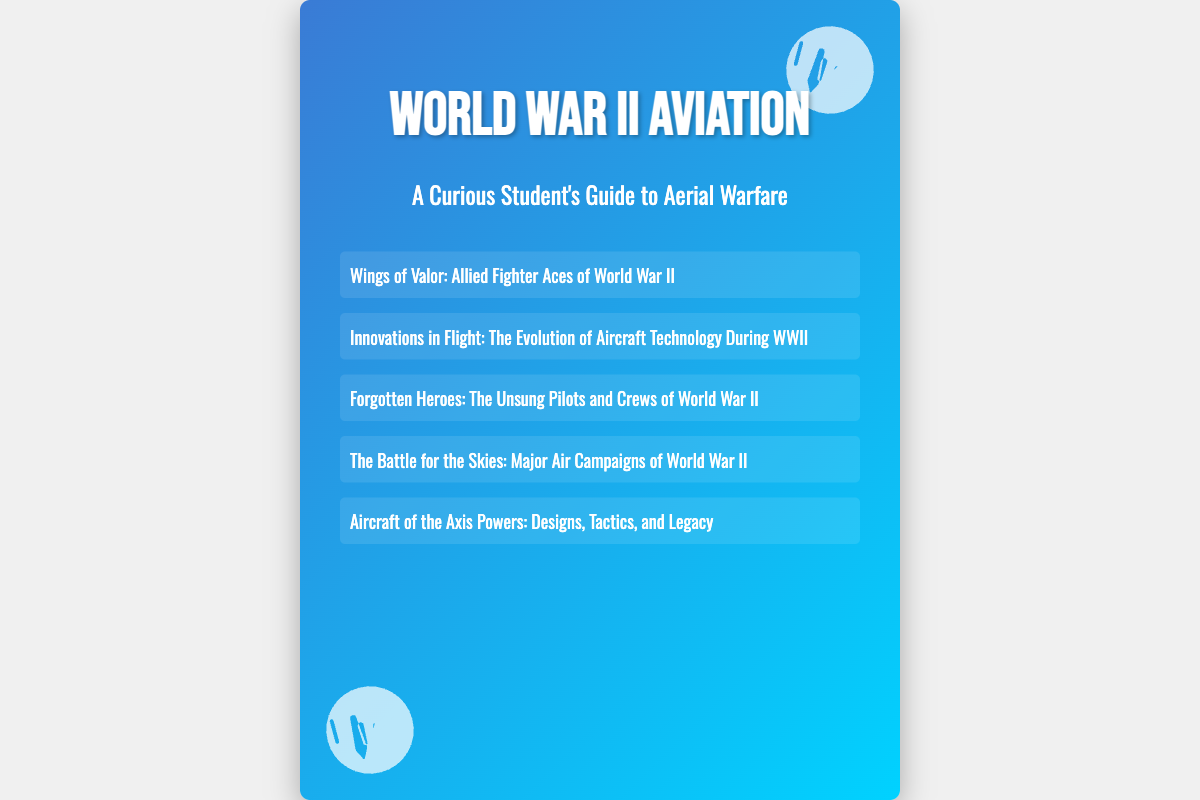what is the title of the first book listed? The title of the first book listed in the document is "Wings of Valor: Allied Fighter Aces of World War II."
Answer: Wings of Valor: Allied Fighter Aces of World War II how many books are listed on the cover? The document contains a list of five books on the cover.
Answer: five which book focuses on technological advancements? The book that focuses on technological advancements is titled "Innovations in Flight: The Evolution of Aircraft Technology During WWII."
Answer: Innovations in Flight: The Evolution of Aircraft Technology During WWII what is the subtitle of the document? The subtitle provided in the document is "A Curious Student's Guide to Aerial Warfare."
Answer: A Curious Student's Guide to Aerial Warfare which type of heroes do the stories in one of the books highlight? The stories in the book highlight "Unsung Pilots and Crews" who contributed to the war effort.
Answer: Unsung Pilots and Crews what theme does "The Battle for the Skies" cover? "The Battle for the Skies" covers major air campaigns during World War II, including significant air battles.
Answer: Major air campaigns during World War II which countries' aircrafts are profiled in "Aircraft of the Axis Powers"? The book profiles aircraft from Germany, Japan, and Italy.
Answer: Germany, Japan, and Italy 